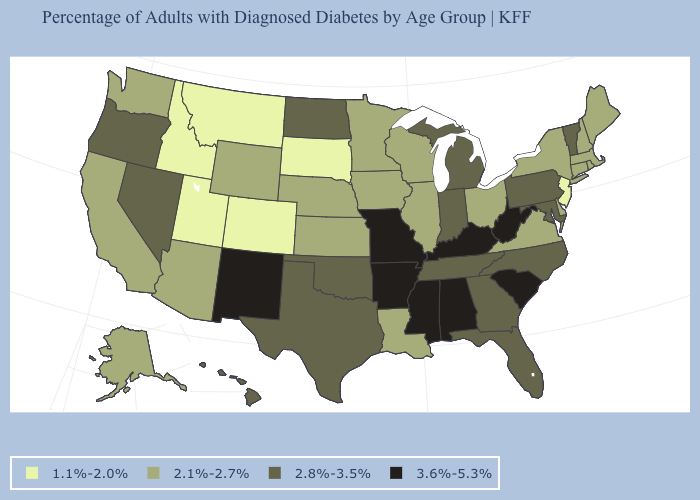What is the lowest value in states that border Delaware?
Concise answer only. 1.1%-2.0%. Name the states that have a value in the range 1.1%-2.0%?
Quick response, please. Colorado, Idaho, Montana, New Jersey, South Dakota, Utah. What is the highest value in the USA?
Short answer required. 3.6%-5.3%. What is the value of New York?
Short answer required. 2.1%-2.7%. Name the states that have a value in the range 2.8%-3.5%?
Keep it brief. Florida, Georgia, Hawaii, Indiana, Maryland, Michigan, Nevada, North Carolina, North Dakota, Oklahoma, Oregon, Pennsylvania, Tennessee, Texas, Vermont. Does the first symbol in the legend represent the smallest category?
Concise answer only. Yes. Name the states that have a value in the range 2.1%-2.7%?
Answer briefly. Alaska, Arizona, California, Connecticut, Delaware, Illinois, Iowa, Kansas, Louisiana, Maine, Massachusetts, Minnesota, Nebraska, New Hampshire, New York, Ohio, Rhode Island, Virginia, Washington, Wisconsin, Wyoming. How many symbols are there in the legend?
Answer briefly. 4. Is the legend a continuous bar?
Quick response, please. No. What is the highest value in states that border Utah?
Quick response, please. 3.6%-5.3%. What is the value of Utah?
Give a very brief answer. 1.1%-2.0%. Name the states that have a value in the range 3.6%-5.3%?
Quick response, please. Alabama, Arkansas, Kentucky, Mississippi, Missouri, New Mexico, South Carolina, West Virginia. Does Pennsylvania have the lowest value in the USA?
Keep it brief. No. Name the states that have a value in the range 1.1%-2.0%?
Be succinct. Colorado, Idaho, Montana, New Jersey, South Dakota, Utah. What is the highest value in the USA?
Concise answer only. 3.6%-5.3%. 